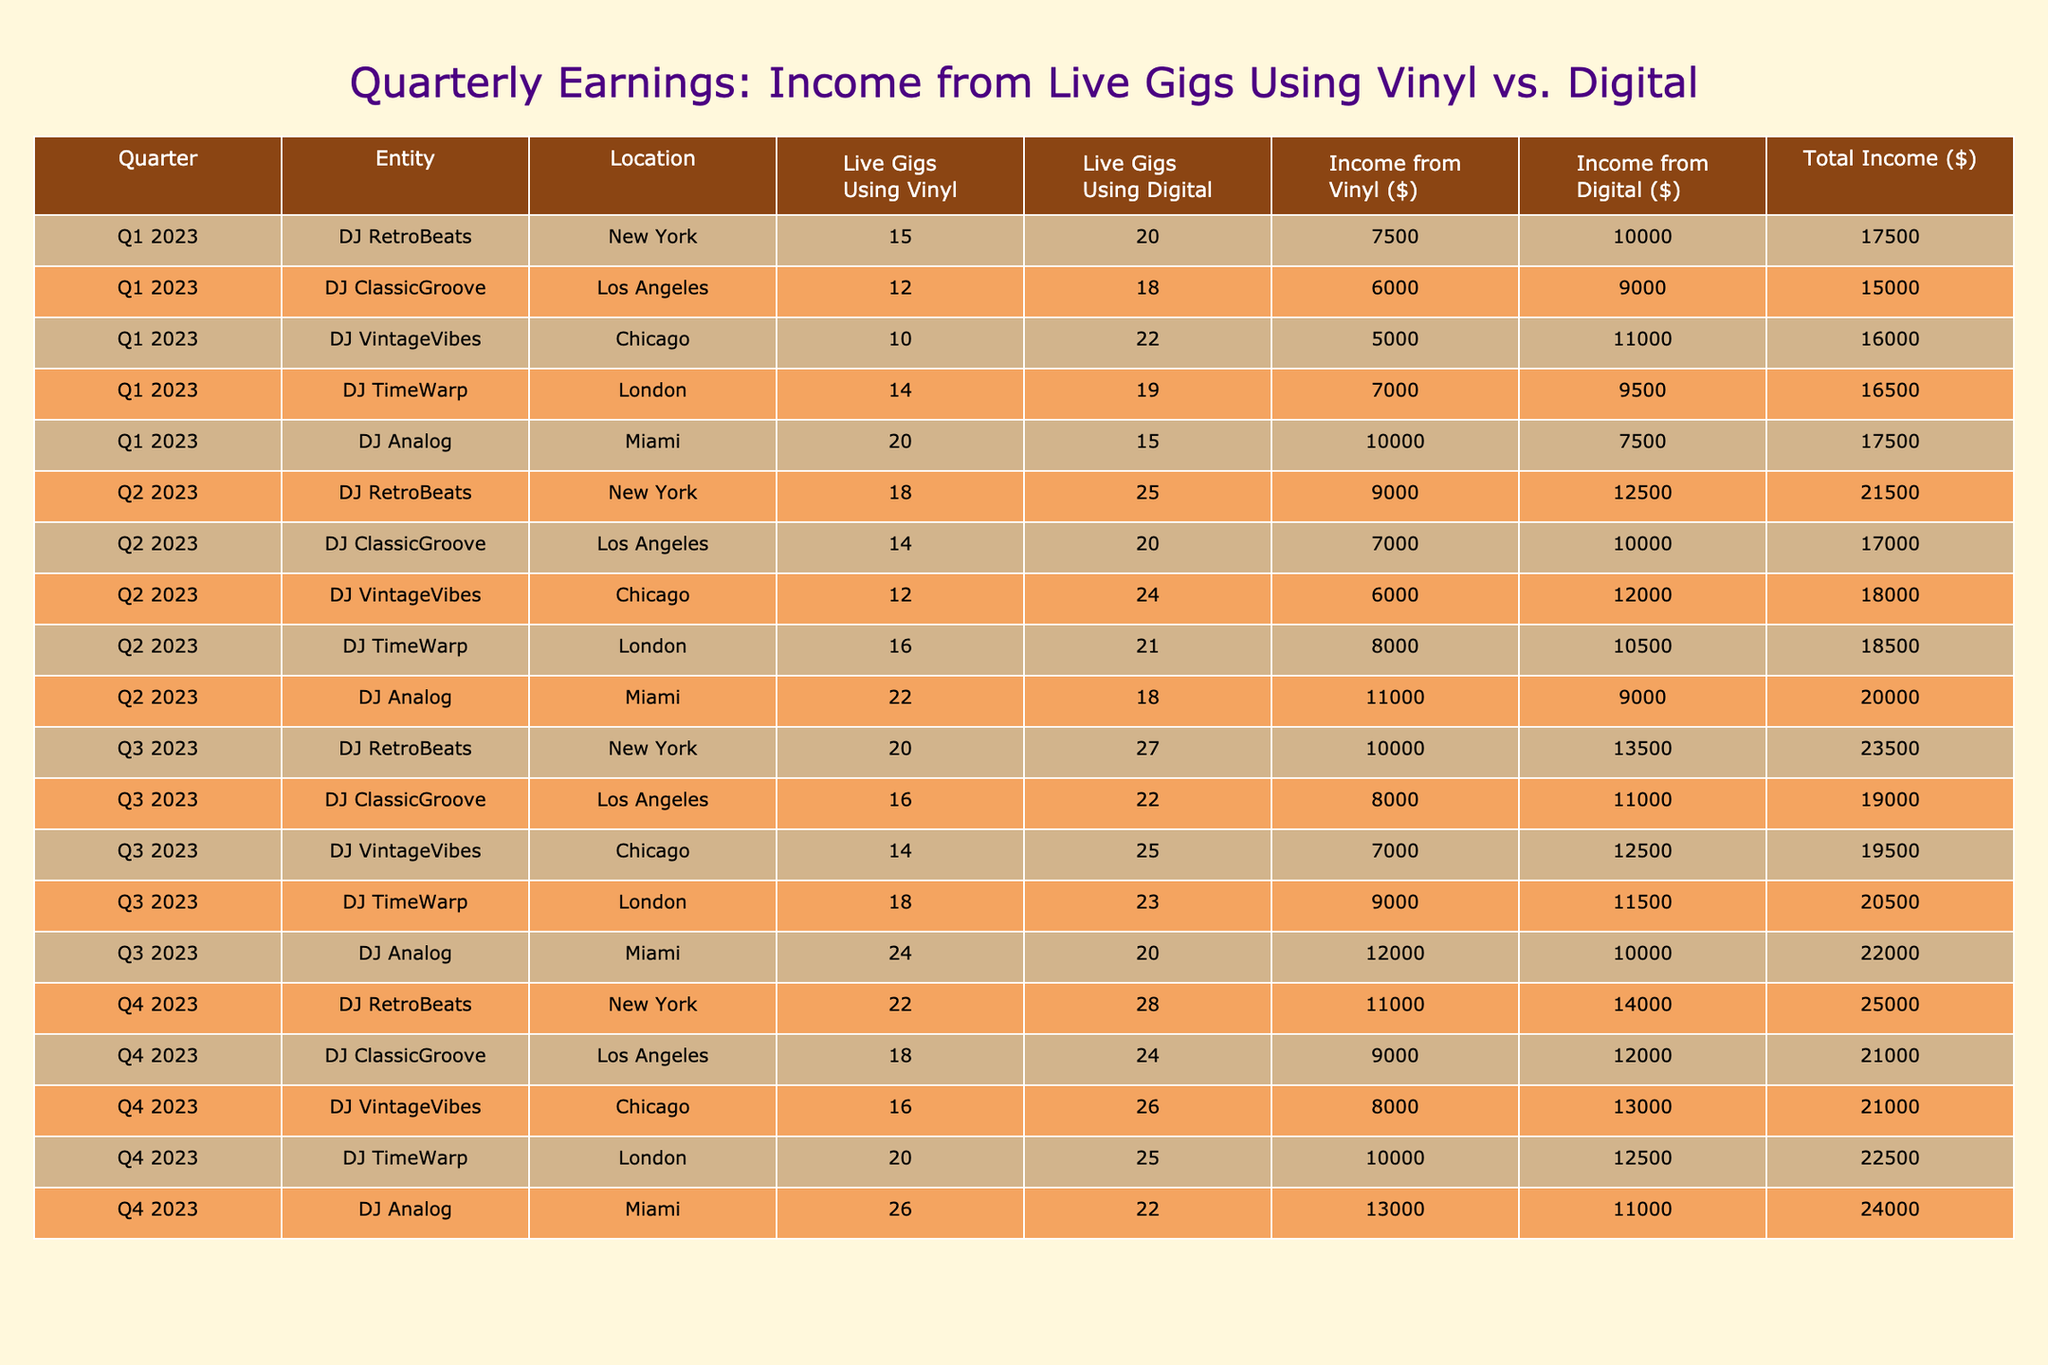What was the total income from live gigs using vinyl for DJ RetroBeats in Q1 2023? The income from vinyl for DJ RetroBeats in Q1 2023 is directly stated in the table as 7500 dollars.
Answer: 7500 What was the difference in the number of live gigs using vinyl between DJ ClassicGroove in Q1 2023 and Q2 2023? In Q1 2023, DJ ClassicGroove had 12 live gigs using vinyl, and in Q2 2023, he had 14. The difference is 14 - 12 = 2.
Answer: 2 Did DJ Analog earn more from digital gigs than from vinyl gigs in Q3 2023? The income from digital gigs for DJ Analog in Q3 2023 is 10000 dollars, while the income from vinyl is 12000 dollars. Thus, he did not earn more from digital than from vinyl.
Answer: No What is the average income from digital gigs across all DJs in Q4 2023? The incomes from digital gigs for Q4 2023 are 14000, 12000, 13000, 12500, and 11000. Adding these gives us 14000 + 12000 + 13000 + 12500 + 11000 = 62500. There are 5 values, so the average is 62500 / 5 = 12500.
Answer: 12500 Which DJ had the highest total income from live gigs in Q2 2023, and what was that amount? To find the total income for each DJ in Q2 2023, we add their income from vinyl and digital. For DJ RetroBeats: 9000 + 12500 = 21500; DJ ClassicGroove: 7000 + 10000 = 17000; DJ VintageVibes: 6000 + 12000 = 18000; DJ TimeWarp: 8000 + 10500 = 18500; DJ Analog: 11000 + 9000 = 20000. The highest income is 21500 from DJ RetroBeats.
Answer: DJ RetroBeats, 21500 What is the total number of live gigs using vinyl for DJ VintageVibes across all quarters? Summing the vinyl gigs for DJ VintageVibes gives us 10 (Q1) + 12 (Q2) + 14 (Q3) + 16 (Q4) = 52.
Answer: 52 